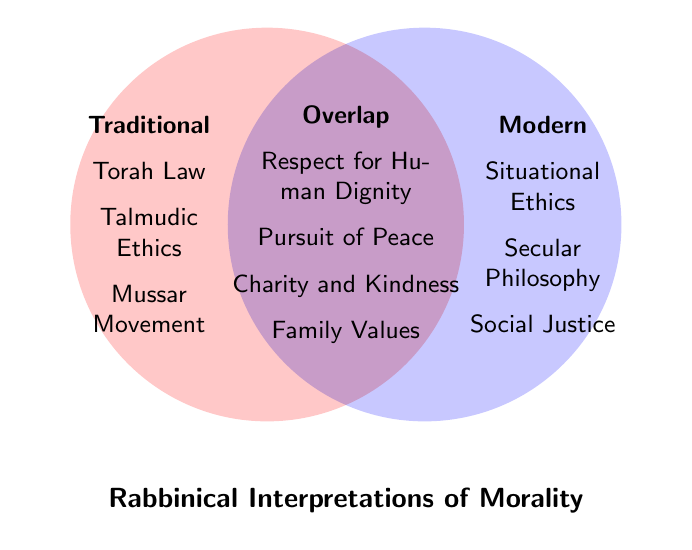What are the traditional elements listed in the diagram? The traditional elements are found in the left circle labeled "Traditional." These include Torah Law, Talmudic Ethics, and Mussar Movement.
Answer: Torah Law, Talmudic Ethics, Mussar Movement How many elements are listed under "Modern"? The modern elements are found in the right circle labeled "Modern." There are three elements: Situational Ethics, Secular Philosophy, and Social Justice.
Answer: 3 Which values are shared between Traditional and Modern interpretations? The values common to both interpretations are listed in the overlapping area of the Venn Diagram. These include Respect for Human Dignity, Pursuit of Peace, Charity and Kindness, and Family Values.
Answer: Respect for Human Dignity, Pursuit of Peace, Charity and Kindness, Family Values What is the total number of unique elements in the diagram? To find the total number of unique elements, count the elements in each circle and the overlapping section without duplication. There are 3 traditional elements, 3 modern elements, and 4 overlapping elements. Thus, 3 + 3 + 4 = 10.
Answer: 10 What similarities exist between Traditional and Modern interpretations according to the diagram? Similarities are indicated by the overlapping section. The overlapping section of the Venn Diagram shows that both hold values such as Respect for Human Dignity, Pursuit of Peace, Charity and Kindness, and Family Values.
Answer: Respect for Human Dignity, Pursuit of Peace, Charity and Kindness, Family Values Are there more traditional or modern elements? The traditional elements are in the left circle, and the modern elements are in the right circle. Both have 3 elements each (Traditional: Torah Law, Talmudic Ethics, Mussar Movement; Modern: Situational Ethics, Secular Philosophy, Social Justice).
Answer: Equal Which category includes "Social Justice"? Looking at the Venn Diagram, "Social Justice" is listed under Modern, which is the right circle.
Answer: Modern Which category includes "Charity and Kindness"? The diagram shows "Charity and Kindness" in the overlap section between Traditional and Modern.
Answer: Overlap 